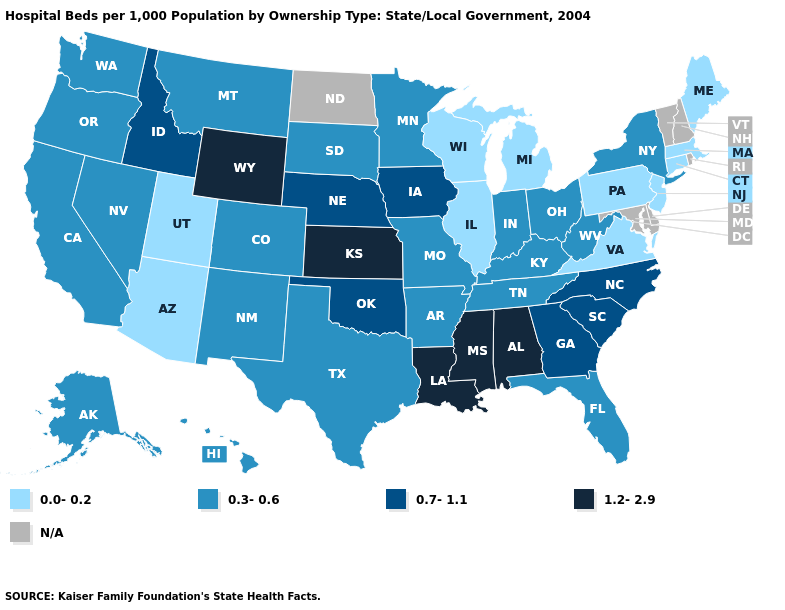What is the lowest value in states that border Kansas?
Short answer required. 0.3-0.6. Which states have the lowest value in the USA?
Be succinct. Arizona, Connecticut, Illinois, Maine, Massachusetts, Michigan, New Jersey, Pennsylvania, Utah, Virginia, Wisconsin. What is the value of Rhode Island?
Concise answer only. N/A. Does Wyoming have the highest value in the West?
Write a very short answer. Yes. Does California have the highest value in the USA?
Concise answer only. No. Does the first symbol in the legend represent the smallest category?
Quick response, please. Yes. Name the states that have a value in the range 0.7-1.1?
Be succinct. Georgia, Idaho, Iowa, Nebraska, North Carolina, Oklahoma, South Carolina. Name the states that have a value in the range 0.3-0.6?
Write a very short answer. Alaska, Arkansas, California, Colorado, Florida, Hawaii, Indiana, Kentucky, Minnesota, Missouri, Montana, Nevada, New Mexico, New York, Ohio, Oregon, South Dakota, Tennessee, Texas, Washington, West Virginia. What is the lowest value in the South?
Answer briefly. 0.0-0.2. Name the states that have a value in the range 0.3-0.6?
Answer briefly. Alaska, Arkansas, California, Colorado, Florida, Hawaii, Indiana, Kentucky, Minnesota, Missouri, Montana, Nevada, New Mexico, New York, Ohio, Oregon, South Dakota, Tennessee, Texas, Washington, West Virginia. Which states have the lowest value in the Northeast?
Quick response, please. Connecticut, Maine, Massachusetts, New Jersey, Pennsylvania. Name the states that have a value in the range 0.0-0.2?
Answer briefly. Arizona, Connecticut, Illinois, Maine, Massachusetts, Michigan, New Jersey, Pennsylvania, Utah, Virginia, Wisconsin. What is the value of Louisiana?
Give a very brief answer. 1.2-2.9. Which states have the highest value in the USA?
Concise answer only. Alabama, Kansas, Louisiana, Mississippi, Wyoming. Name the states that have a value in the range 0.7-1.1?
Keep it brief. Georgia, Idaho, Iowa, Nebraska, North Carolina, Oklahoma, South Carolina. 